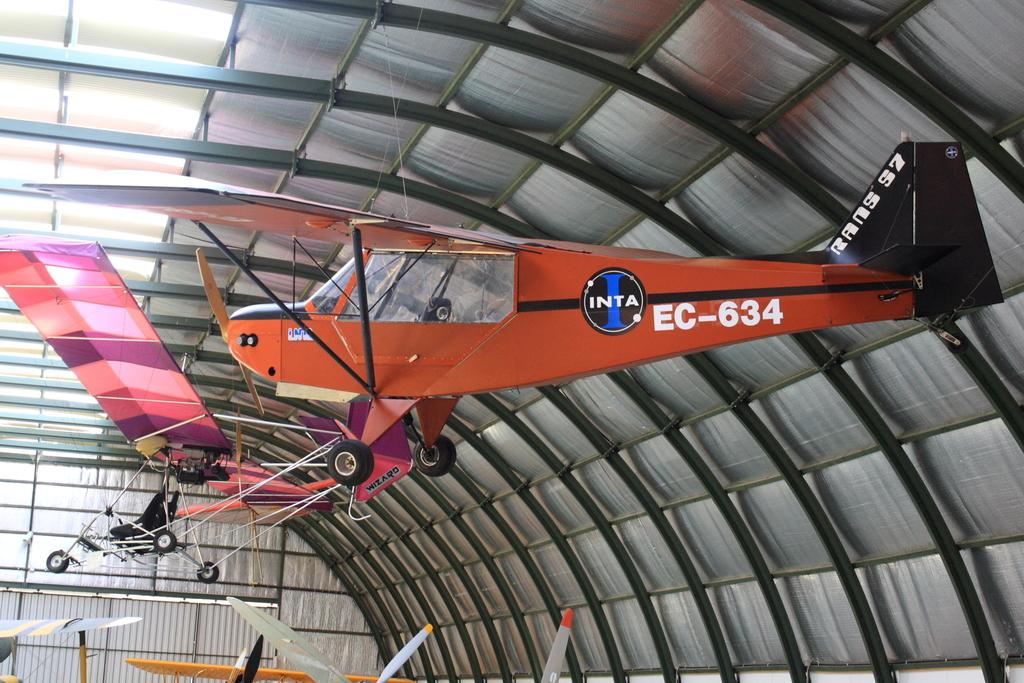<image>
Write a terse but informative summary of the picture. A red airplane with the word Inta written on the side 